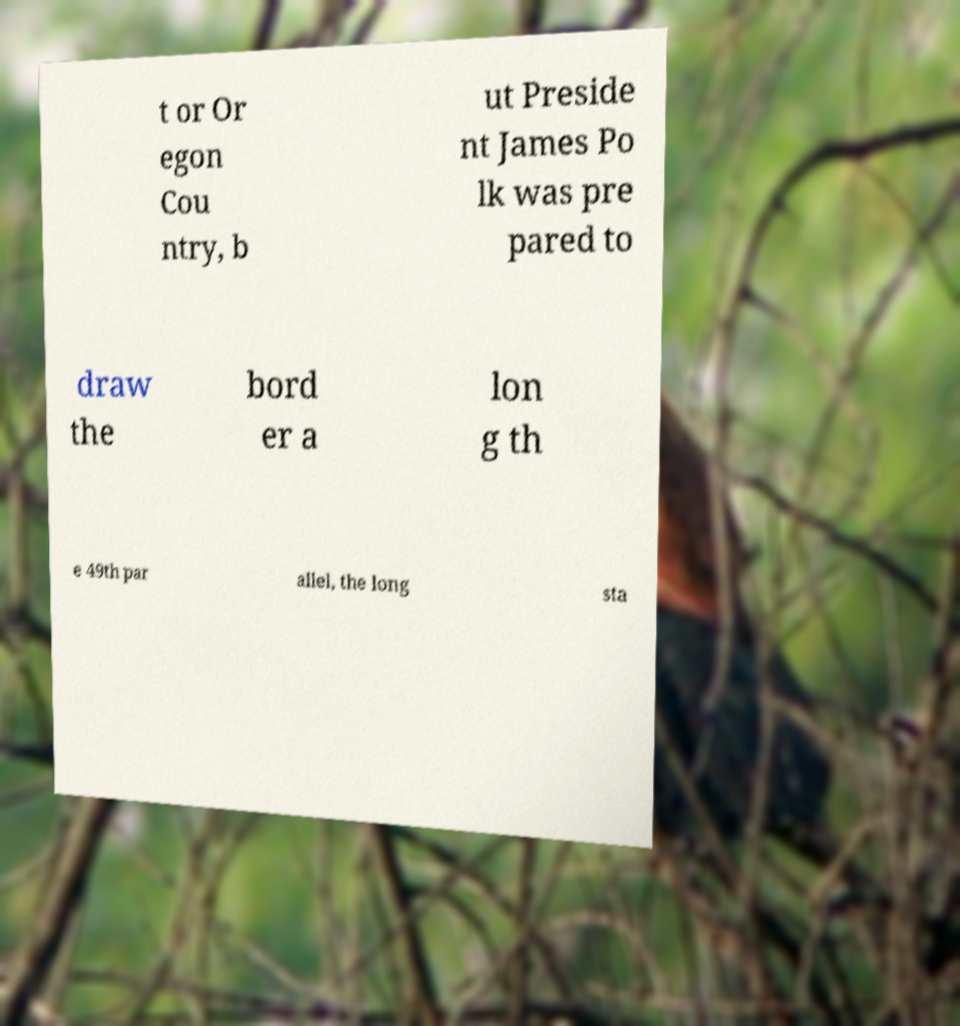Can you read and provide the text displayed in the image?This photo seems to have some interesting text. Can you extract and type it out for me? t or Or egon Cou ntry, b ut Preside nt James Po lk was pre pared to draw the bord er a lon g th e 49th par allel, the long sta 